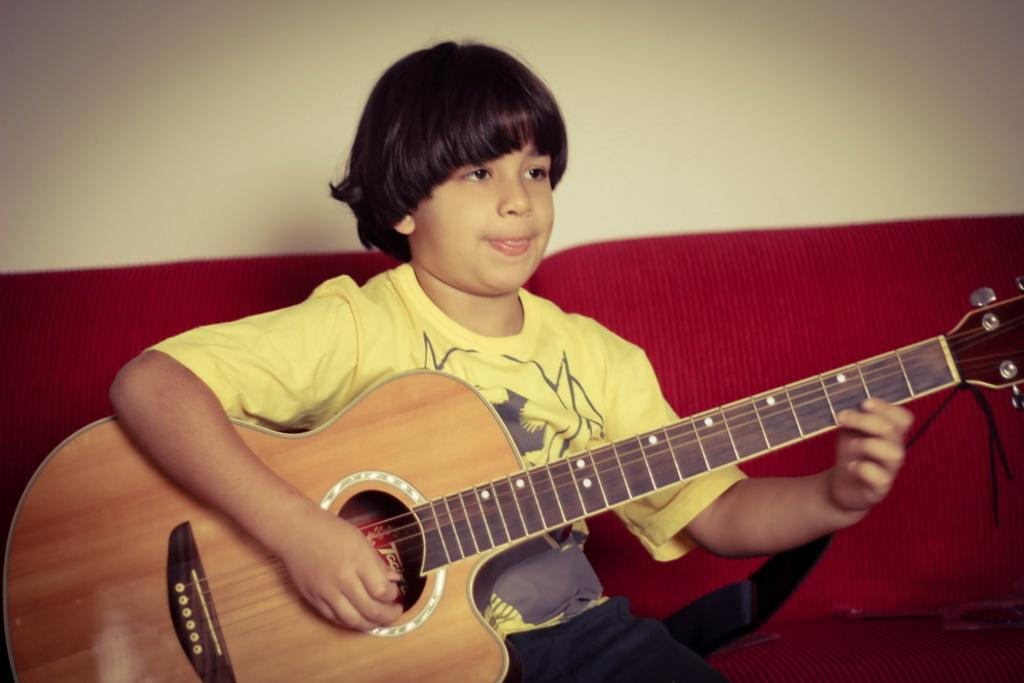What is the main subject of the image? There is a child in the image. Where is the child located? The child is sitting on a sofa. What is the child holding? The child is holding a guitar. What is the child doing with the guitar? The child is playing the guitar. How many giants are visible in the image? There are no giants present in the image. What type of fish can be seen swimming in the guitar strings? There are no fish visible in the image, and the guitar strings are not depicted as a body of water for fish to swim in. 